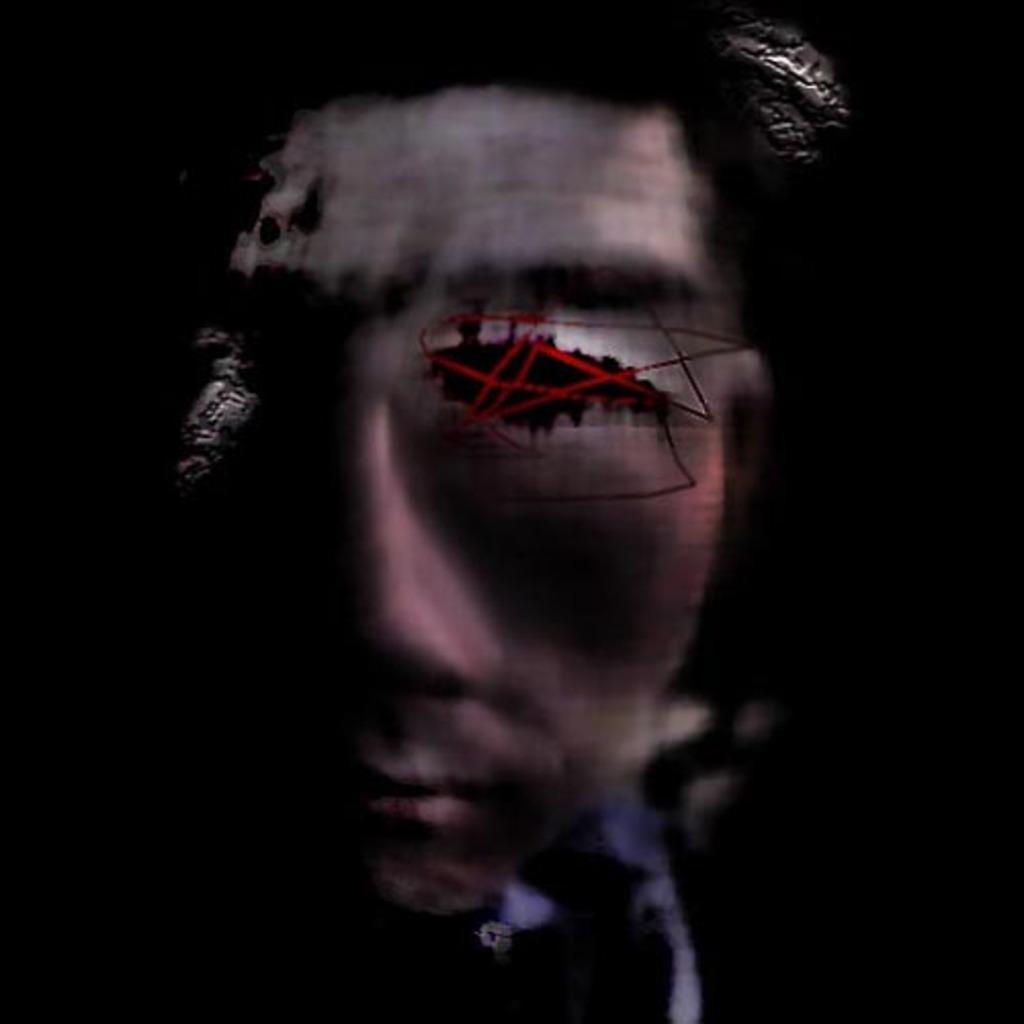Please provide a concise description of this image. In this picture I can observe a graphic. There is a face of a person. The background is completely dark. 